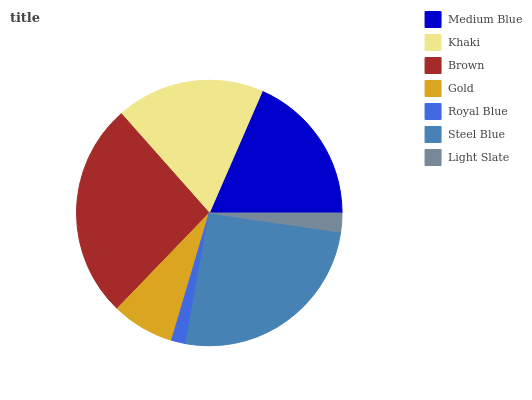Is Royal Blue the minimum?
Answer yes or no. Yes. Is Brown the maximum?
Answer yes or no. Yes. Is Khaki the minimum?
Answer yes or no. No. Is Khaki the maximum?
Answer yes or no. No. Is Medium Blue greater than Khaki?
Answer yes or no. Yes. Is Khaki less than Medium Blue?
Answer yes or no. Yes. Is Khaki greater than Medium Blue?
Answer yes or no. No. Is Medium Blue less than Khaki?
Answer yes or no. No. Is Khaki the high median?
Answer yes or no. Yes. Is Khaki the low median?
Answer yes or no. Yes. Is Brown the high median?
Answer yes or no. No. Is Steel Blue the low median?
Answer yes or no. No. 